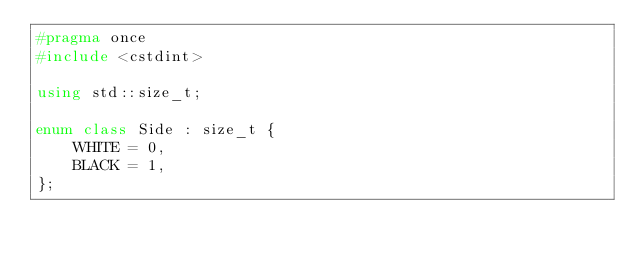Convert code to text. <code><loc_0><loc_0><loc_500><loc_500><_C++_>#pragma once
#include <cstdint>

using std::size_t;

enum class Side : size_t {
    WHITE = 0,
    BLACK = 1,
};</code> 